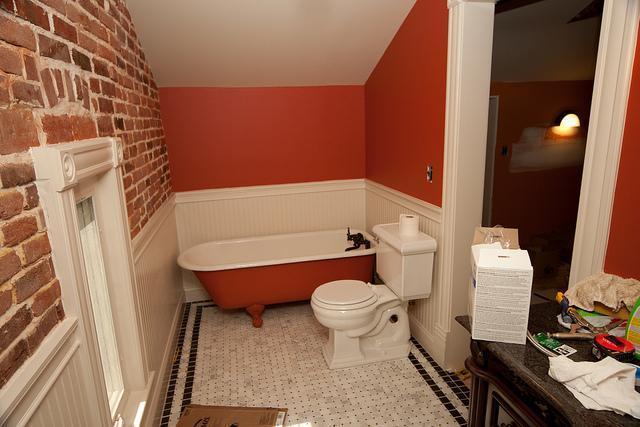How many toilets are visible?
Give a very brief answer. 1. How many people are in the picture?
Give a very brief answer. 0. 